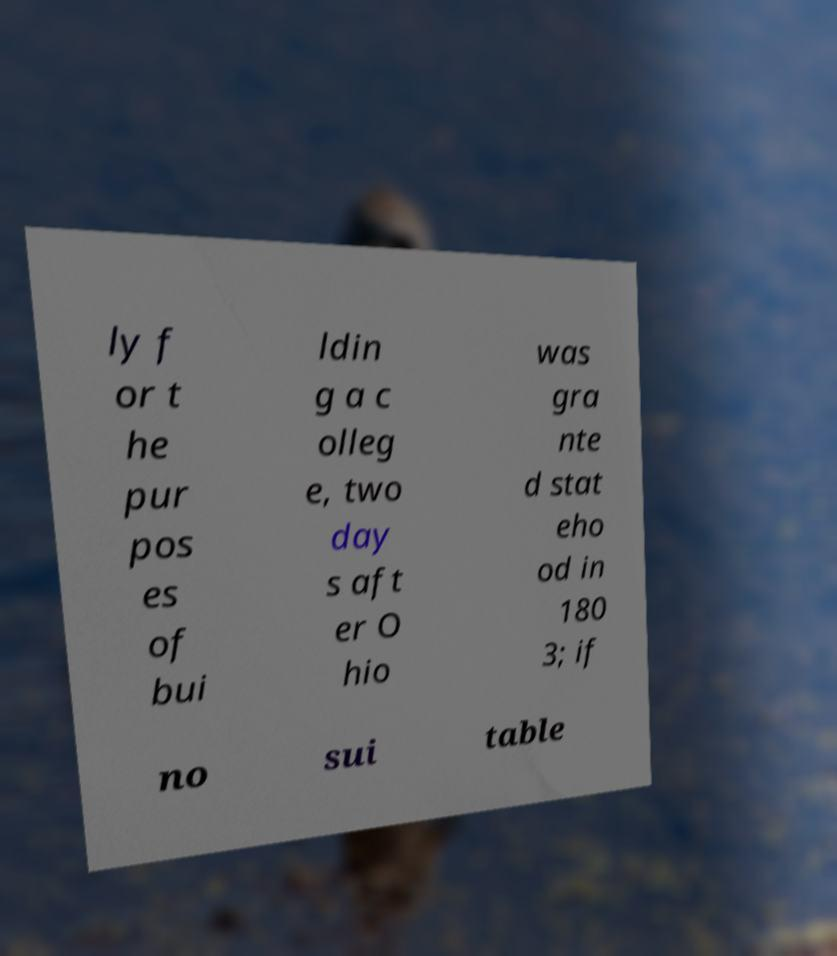Please identify and transcribe the text found in this image. ly f or t he pur pos es of bui ldin g a c olleg e, two day s aft er O hio was gra nte d stat eho od in 180 3; if no sui table 